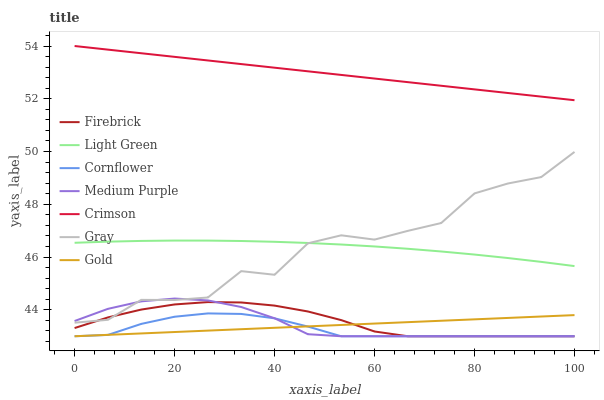Does Gold have the minimum area under the curve?
Answer yes or no. No. Does Gold have the maximum area under the curve?
Answer yes or no. No. Is Gray the smoothest?
Answer yes or no. No. Is Gold the roughest?
Answer yes or no. No. Does Gray have the lowest value?
Answer yes or no. No. Does Gray have the highest value?
Answer yes or no. No. Is Gold less than Gray?
Answer yes or no. Yes. Is Light Green greater than Gold?
Answer yes or no. Yes. Does Gold intersect Gray?
Answer yes or no. No. 